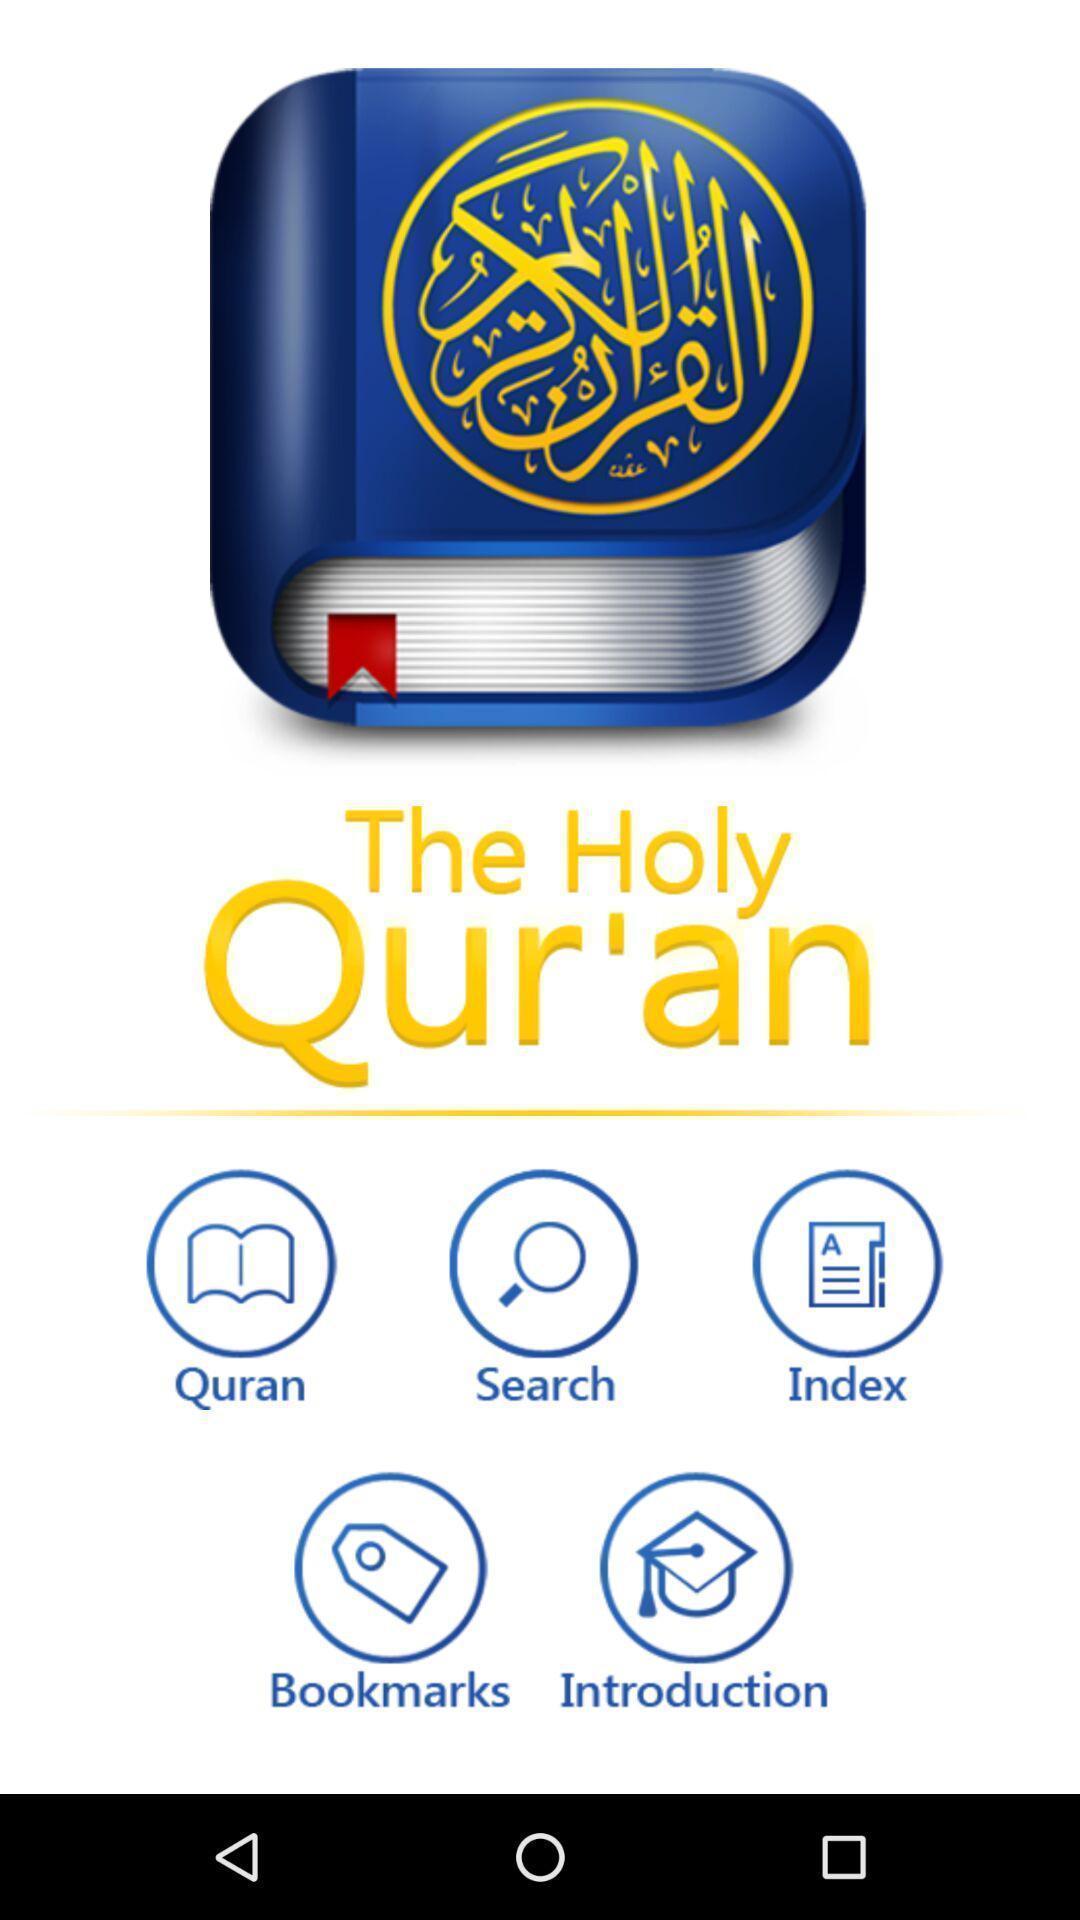What can you discern from this picture? Welcome page. 